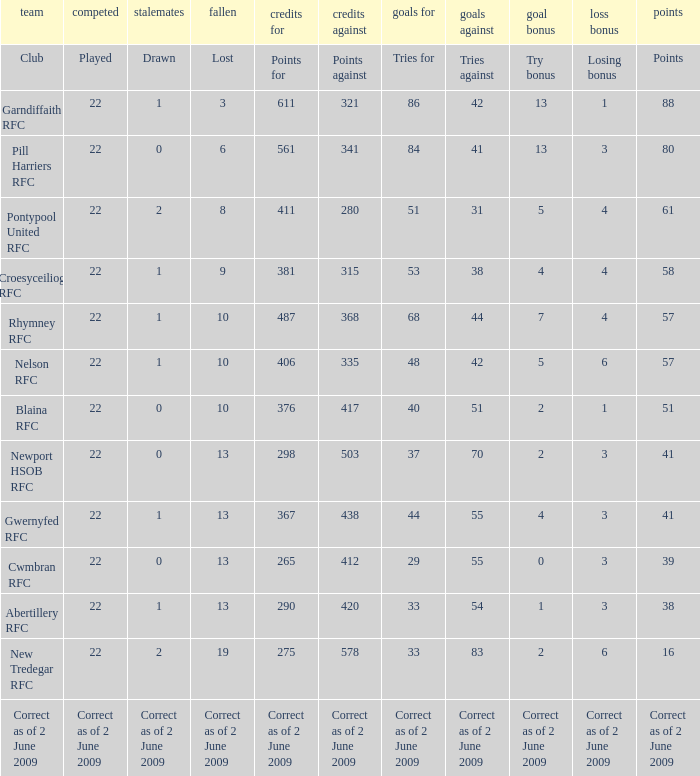Could you parse the entire table? {'header': ['team', 'competed', 'stalemates', 'fallen', 'credits for', 'credits against', 'goals for', 'goals against', 'goal bonus', 'loss bonus', 'points'], 'rows': [['Club', 'Played', 'Drawn', 'Lost', 'Points for', 'Points against', 'Tries for', 'Tries against', 'Try bonus', 'Losing bonus', 'Points'], ['Garndiffaith RFC', '22', '1', '3', '611', '321', '86', '42', '13', '1', '88'], ['Pill Harriers RFC', '22', '0', '6', '561', '341', '84', '41', '13', '3', '80'], ['Pontypool United RFC', '22', '2', '8', '411', '280', '51', '31', '5', '4', '61'], ['Croesyceiliog RFC', '22', '1', '9', '381', '315', '53', '38', '4', '4', '58'], ['Rhymney RFC', '22', '1', '10', '487', '368', '68', '44', '7', '4', '57'], ['Nelson RFC', '22', '1', '10', '406', '335', '48', '42', '5', '6', '57'], ['Blaina RFC', '22', '0', '10', '376', '417', '40', '51', '2', '1', '51'], ['Newport HSOB RFC', '22', '0', '13', '298', '503', '37', '70', '2', '3', '41'], ['Gwernyfed RFC', '22', '1', '13', '367', '438', '44', '55', '4', '3', '41'], ['Cwmbran RFC', '22', '0', '13', '265', '412', '29', '55', '0', '3', '39'], ['Abertillery RFC', '22', '1', '13', '290', '420', '33', '54', '1', '3', '38'], ['New Tredegar RFC', '22', '2', '19', '275', '578', '33', '83', '2', '6', '16'], ['Correct as of 2 June 2009', 'Correct as of 2 June 2009', 'Correct as of 2 June 2009', 'Correct as of 2 June 2009', 'Correct as of 2 June 2009', 'Correct as of 2 June 2009', 'Correct as of 2 June 2009', 'Correct as of 2 June 2009', 'Correct as of 2 June 2009', 'Correct as of 2 June 2009', 'Correct as of 2 June 2009']]} Which club has 275 points? New Tredegar RFC. 